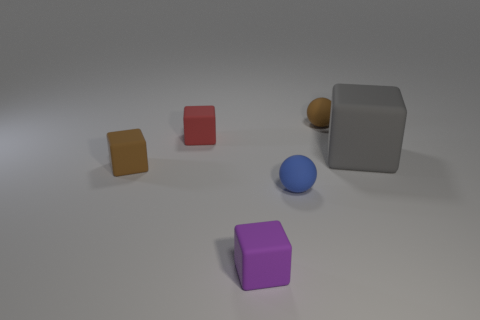What is the color of the cube that is both to the right of the red cube and in front of the gray object?
Your answer should be very brief. Purple. What is the size of the blue ball?
Provide a short and direct response. Small. There is a ball behind the large rubber thing; is its color the same as the large rubber block?
Your response must be concise. No. Is the number of tiny things behind the brown ball greater than the number of objects that are on the left side of the blue rubber sphere?
Your answer should be compact. No. Is the number of big cubes greater than the number of blue metallic things?
Your answer should be compact. Yes. How big is the object that is both in front of the small red matte cube and to the left of the purple thing?
Your answer should be very brief. Small. What is the shape of the large gray rubber thing?
Provide a succinct answer. Cube. Are there any other things that are the same size as the blue matte object?
Keep it short and to the point. Yes. Are there more small blue matte spheres in front of the small blue object than purple blocks?
Give a very brief answer. No. There is a brown matte thing that is in front of the small sphere that is behind the small brown object on the left side of the red matte object; what is its shape?
Offer a terse response. Cube. 